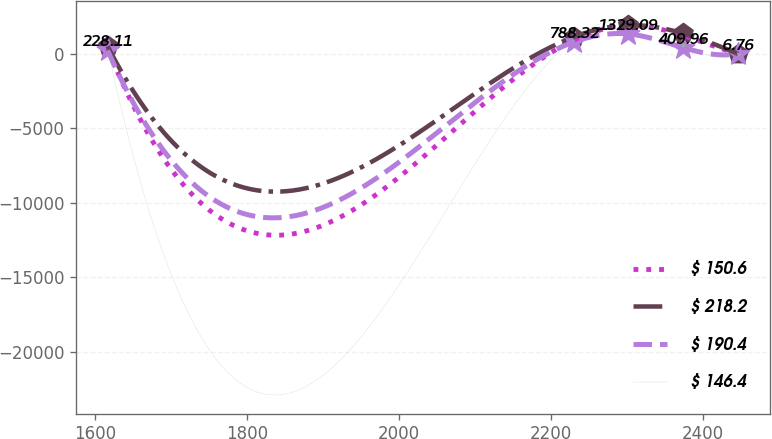Convert chart. <chart><loc_0><loc_0><loc_500><loc_500><line_chart><ecel><fcel>$ 150.6<fcel>$ 218.2<fcel>$ 190.4<fcel>$ 146.4<nl><fcel>1616.33<fcel>372.15<fcel>503.83<fcel>228.11<fcel>354.65<nl><fcel>2229.73<fcel>914.95<fcel>1124.63<fcel>788.32<fcel>985.54<nl><fcel>2301.82<fcel>1890.62<fcel>1917.72<fcel>1329.09<fcel>2246.02<nl><fcel>2373.91<fcel>1222.05<fcel>1363.63<fcel>409.96<fcel>601.98<nl><fcel>2446.01<fcel>1.98<fcel>4.13<fcel>6.76<fcel>9.77<nl></chart> 